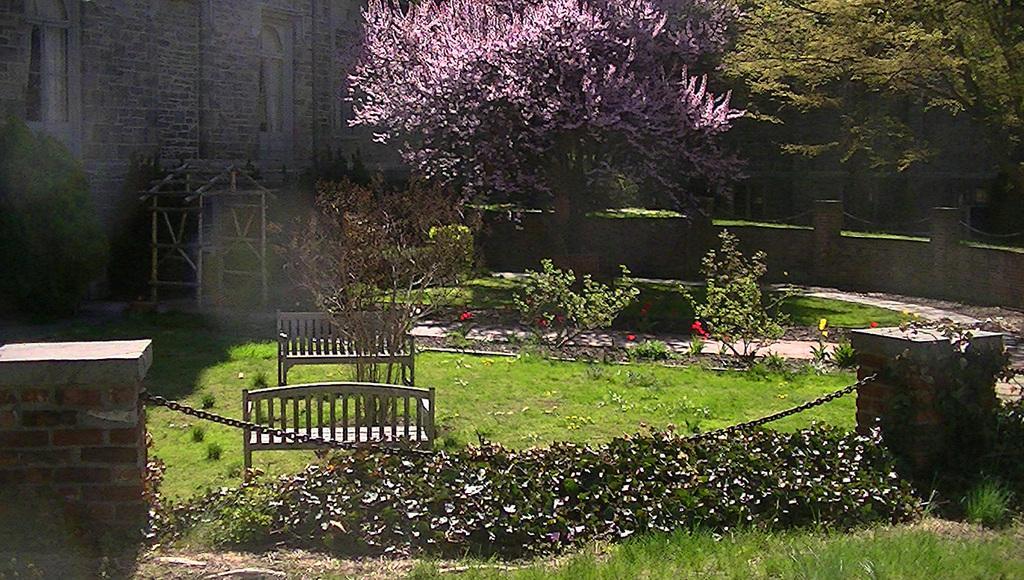How would you summarize this image in a sentence or two? As we can see in the image there is grass, benches, plants, trees and buildings. 